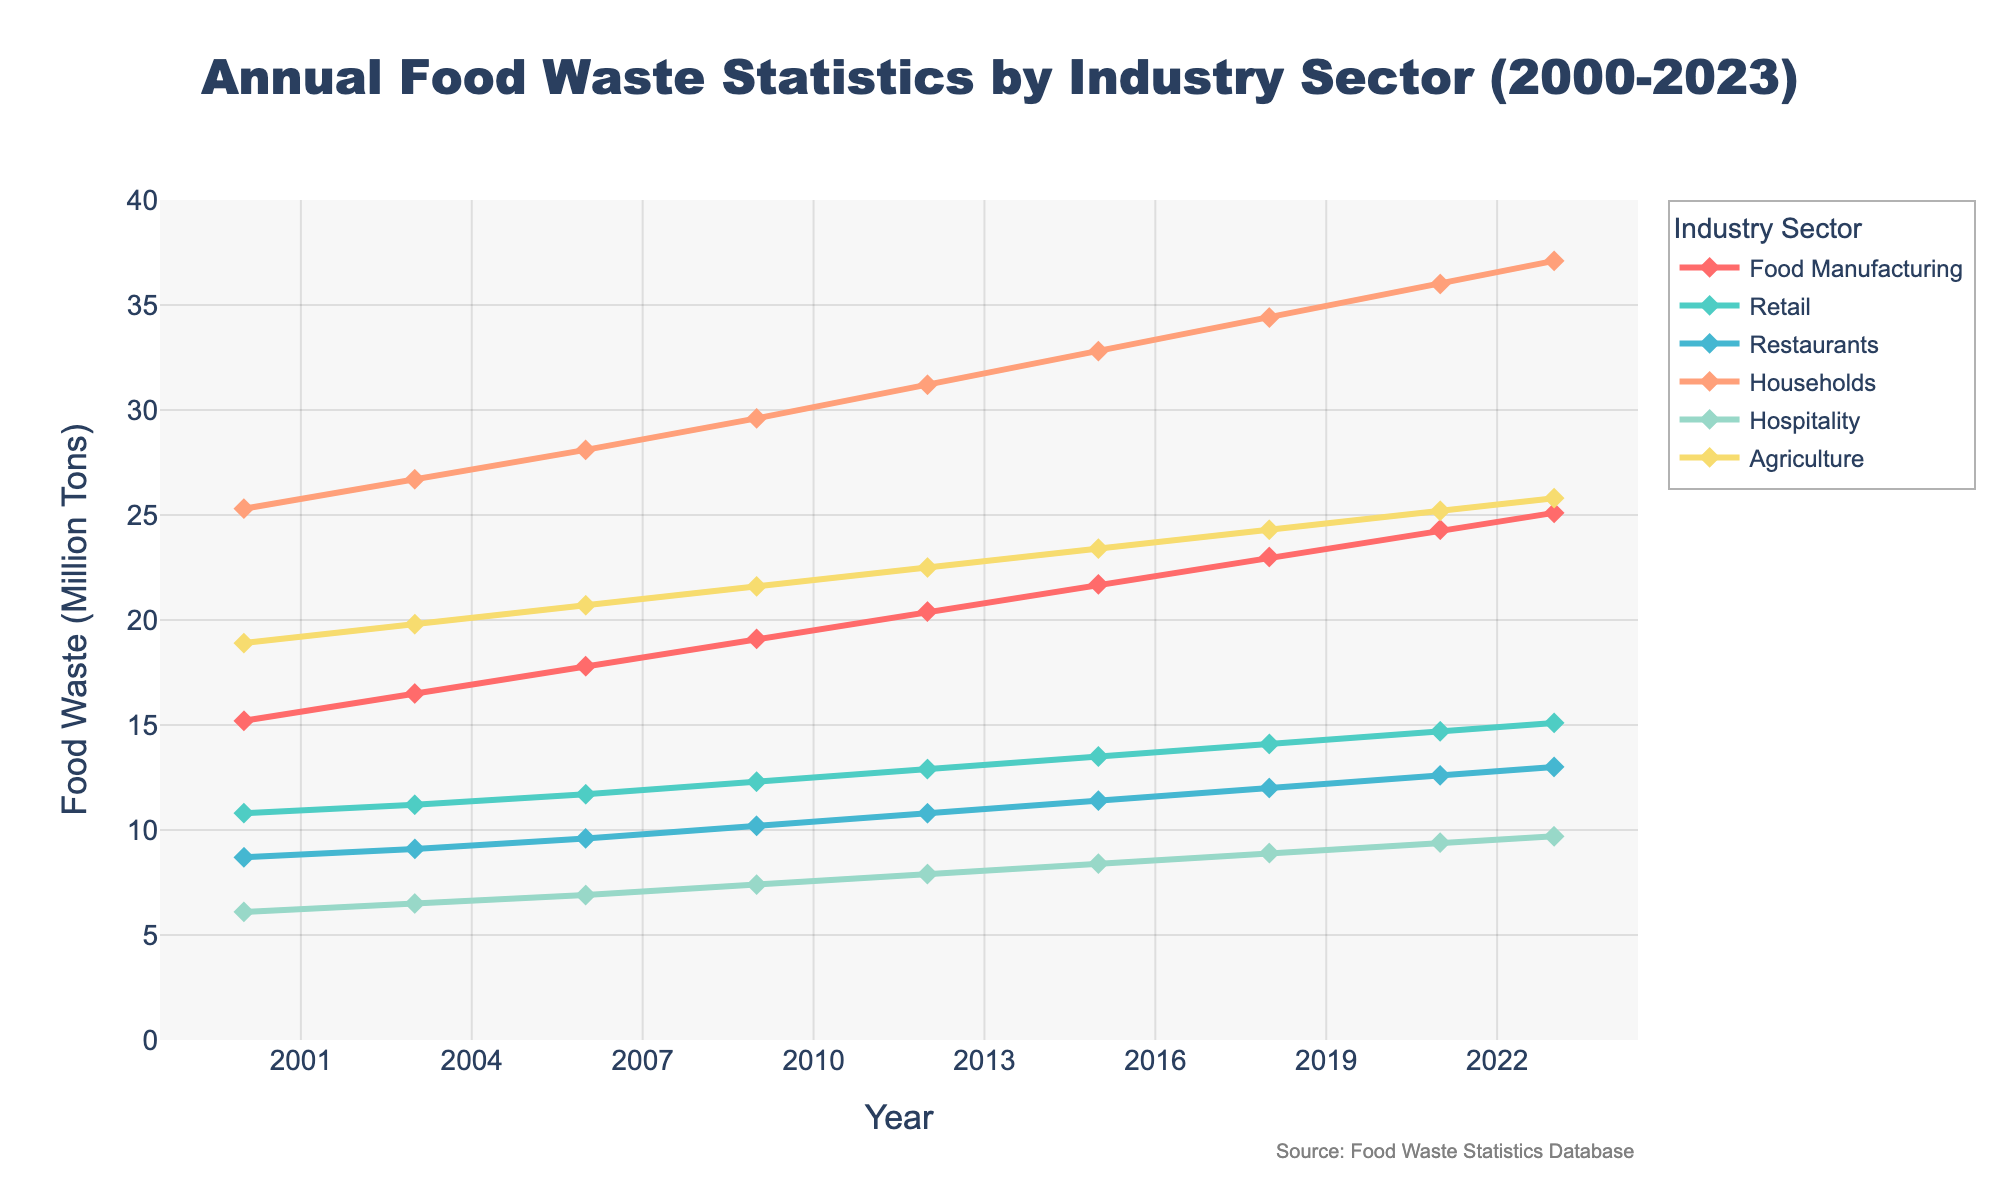what is the overall trend in food waste for households from 2000 to 2023? The chart shows a steady increase in food waste for households, starting at 25.3 million tons in 2000 and reaching 37.1 million tons in 2023. This indicates that household food waste has consistently risen over the years.
Answer: Steady increase Which sector experienced the highest food waste in 2023? By examining the endpoints of the lines in the chart for each sector, we see that the household sector has the highest food waste in 2023, reaching 37.1 million tons.
Answer: Households Did the food manufacturing sector or agriculture sector experience greater growth in food waste from 2000 to 2023? From 2000 to 2023, food manufacturing waste increased from 15.2 to 25.1 million tons, a growth of 9.9 million tons. Agriculture waste increased from 18.9 to 25.8 million tons, a growth of 6.9 million tons. Therefore, food manufacturing experienced greater growth.
Answer: Food manufacturing How does the rate of increase in food waste for restaurants compare to that for hospitality from 2000 to 2023? From 2000 to 2023, restaurant food waste increased from 8.7 to 13.0 million tons, a growth of 4.3 million tons. Hospitality waste increased from 6.1 to 9.7 million tons, a growth of 3.6 million tons. The rate of increase is slightly higher for restaurants compared to hospitality.
Answer: Higher for restaurants What is the difference in food waste between the retail and restaurant sectors in 2021? In 2021, retail food waste is 14.7 million tons, and restaurant food waste is 12.6 million tons. The difference between them is 14.7 - 12.6 = 2.1 million tons.
Answer: 2.1 million tons Which sectors had food waste values exceeding 20 million tons for the first time and in which years? By following the lines for each sector, we identify that:
- Households exceeded 20 million tons before 2000.
- Food manufacturing exceeded 20 million tons in 2012.
- Agriculture exceeded 20 million tons in 2006.
Answer: Households (before 2000), Food Manufacturing (2012), Agriculture (2006) What is the average food waste for the agriculture sector from 2000 to 2023? Agriculture food waste in each year: 18.9, 19.8, 20.7, 21.6, 22.5, 23.4, 24.3, 25.2, 25.8. Sum these values to get 202.2 million tons. Divide by 9 (number of points) to get the average: 202.2 / 9 = 22.47 million tons.
Answer: 22.47 million tons In which year did the retail sector experience a food waste level closest to 15 million tons? Looking at the values for the retail sector: 10.8 (2000), 11.2 (2003), 11.7 (2006), 12.3 (2009), 12.9 (2012), 13.5 (2015), 14.1 (2018), 14.7 (2021), 15.1 (2023), the closest value to 15 million tons is in 2023 with 15.1 million tons.
Answer: 2023 From 2000 to 2023, did any sector experience a decrease in food waste? Examining the trends for each sector (Food Manufacturing, Retail, Restaurants, Households, Hospitality, Agriculture) shows that all sectors have experienced an increase in food waste over the period, with no decreases.
Answer: No 